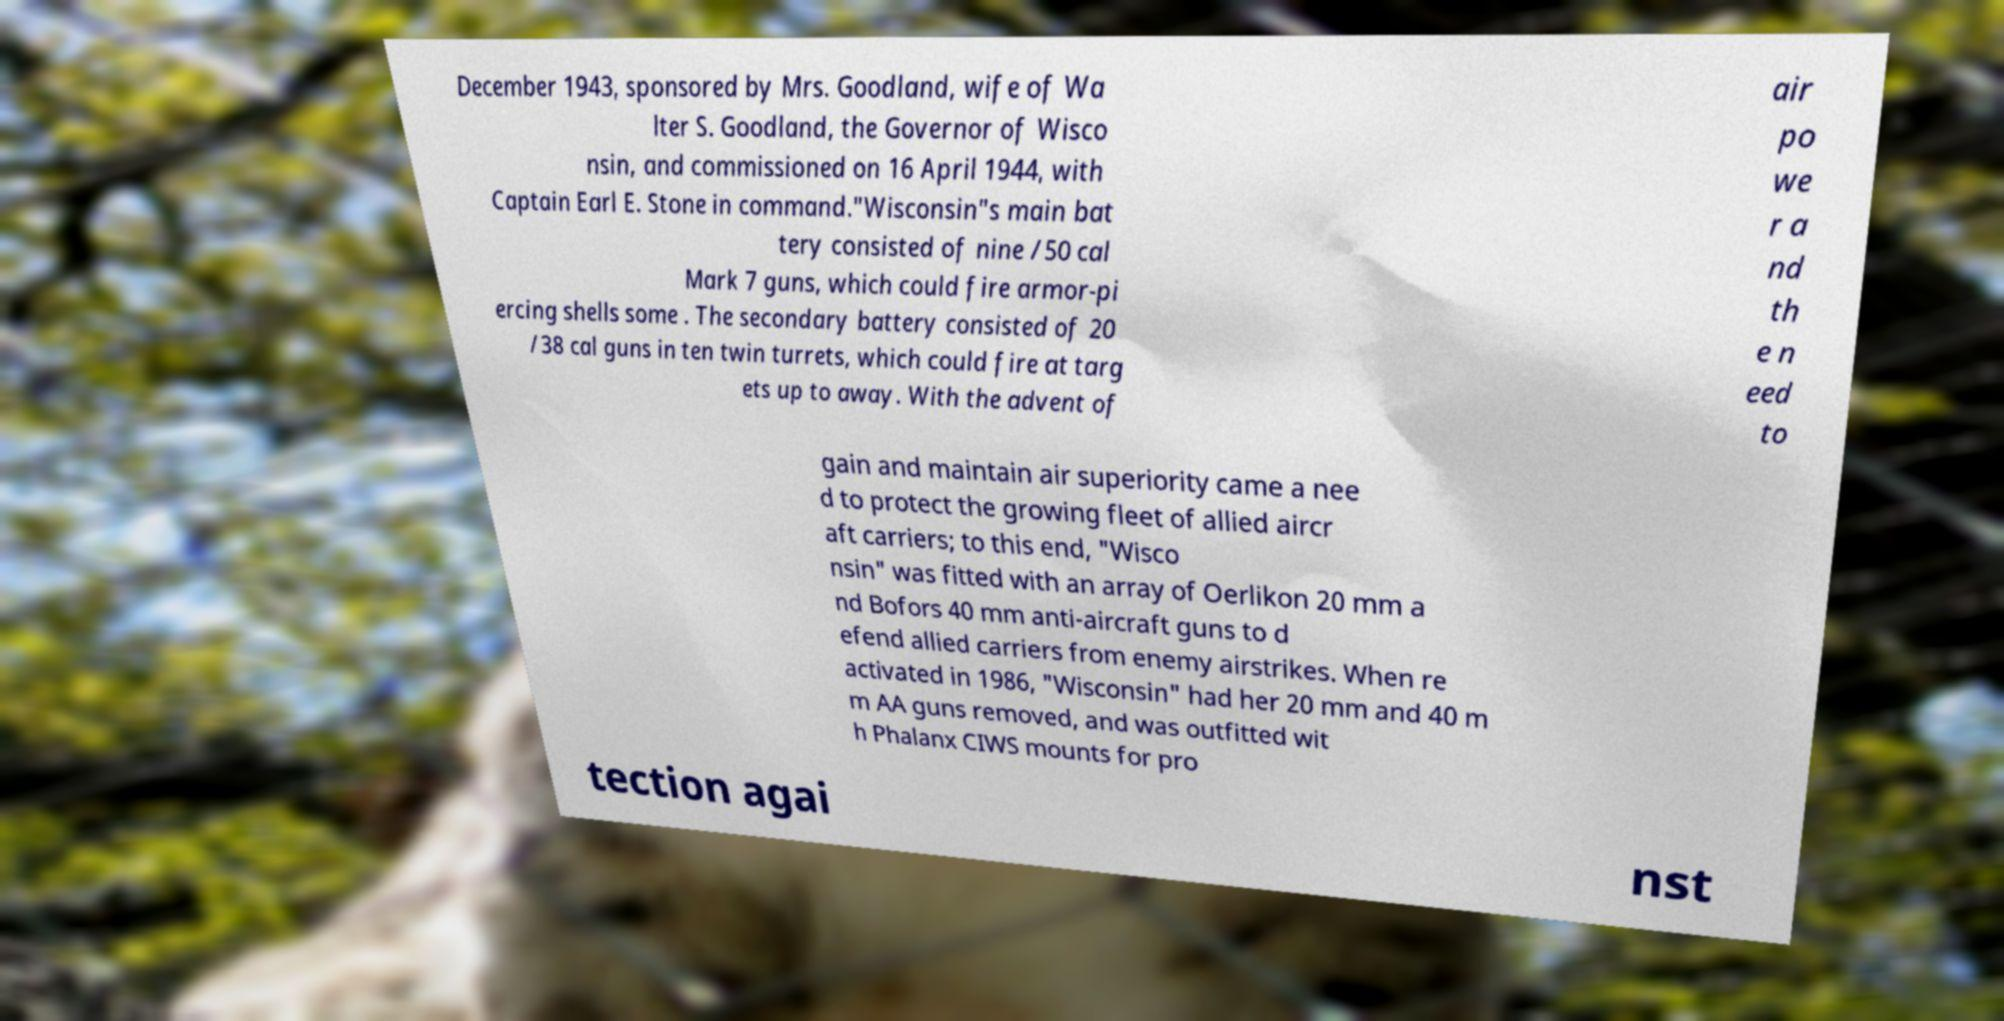There's text embedded in this image that I need extracted. Can you transcribe it verbatim? December 1943, sponsored by Mrs. Goodland, wife of Wa lter S. Goodland, the Governor of Wisco nsin, and commissioned on 16 April 1944, with Captain Earl E. Stone in command."Wisconsin"s main bat tery consisted of nine /50 cal Mark 7 guns, which could fire armor-pi ercing shells some . The secondary battery consisted of 20 /38 cal guns in ten twin turrets, which could fire at targ ets up to away. With the advent of air po we r a nd th e n eed to gain and maintain air superiority came a nee d to protect the growing fleet of allied aircr aft carriers; to this end, "Wisco nsin" was fitted with an array of Oerlikon 20 mm a nd Bofors 40 mm anti-aircraft guns to d efend allied carriers from enemy airstrikes. When re activated in 1986, "Wisconsin" had her 20 mm and 40 m m AA guns removed, and was outfitted wit h Phalanx CIWS mounts for pro tection agai nst 